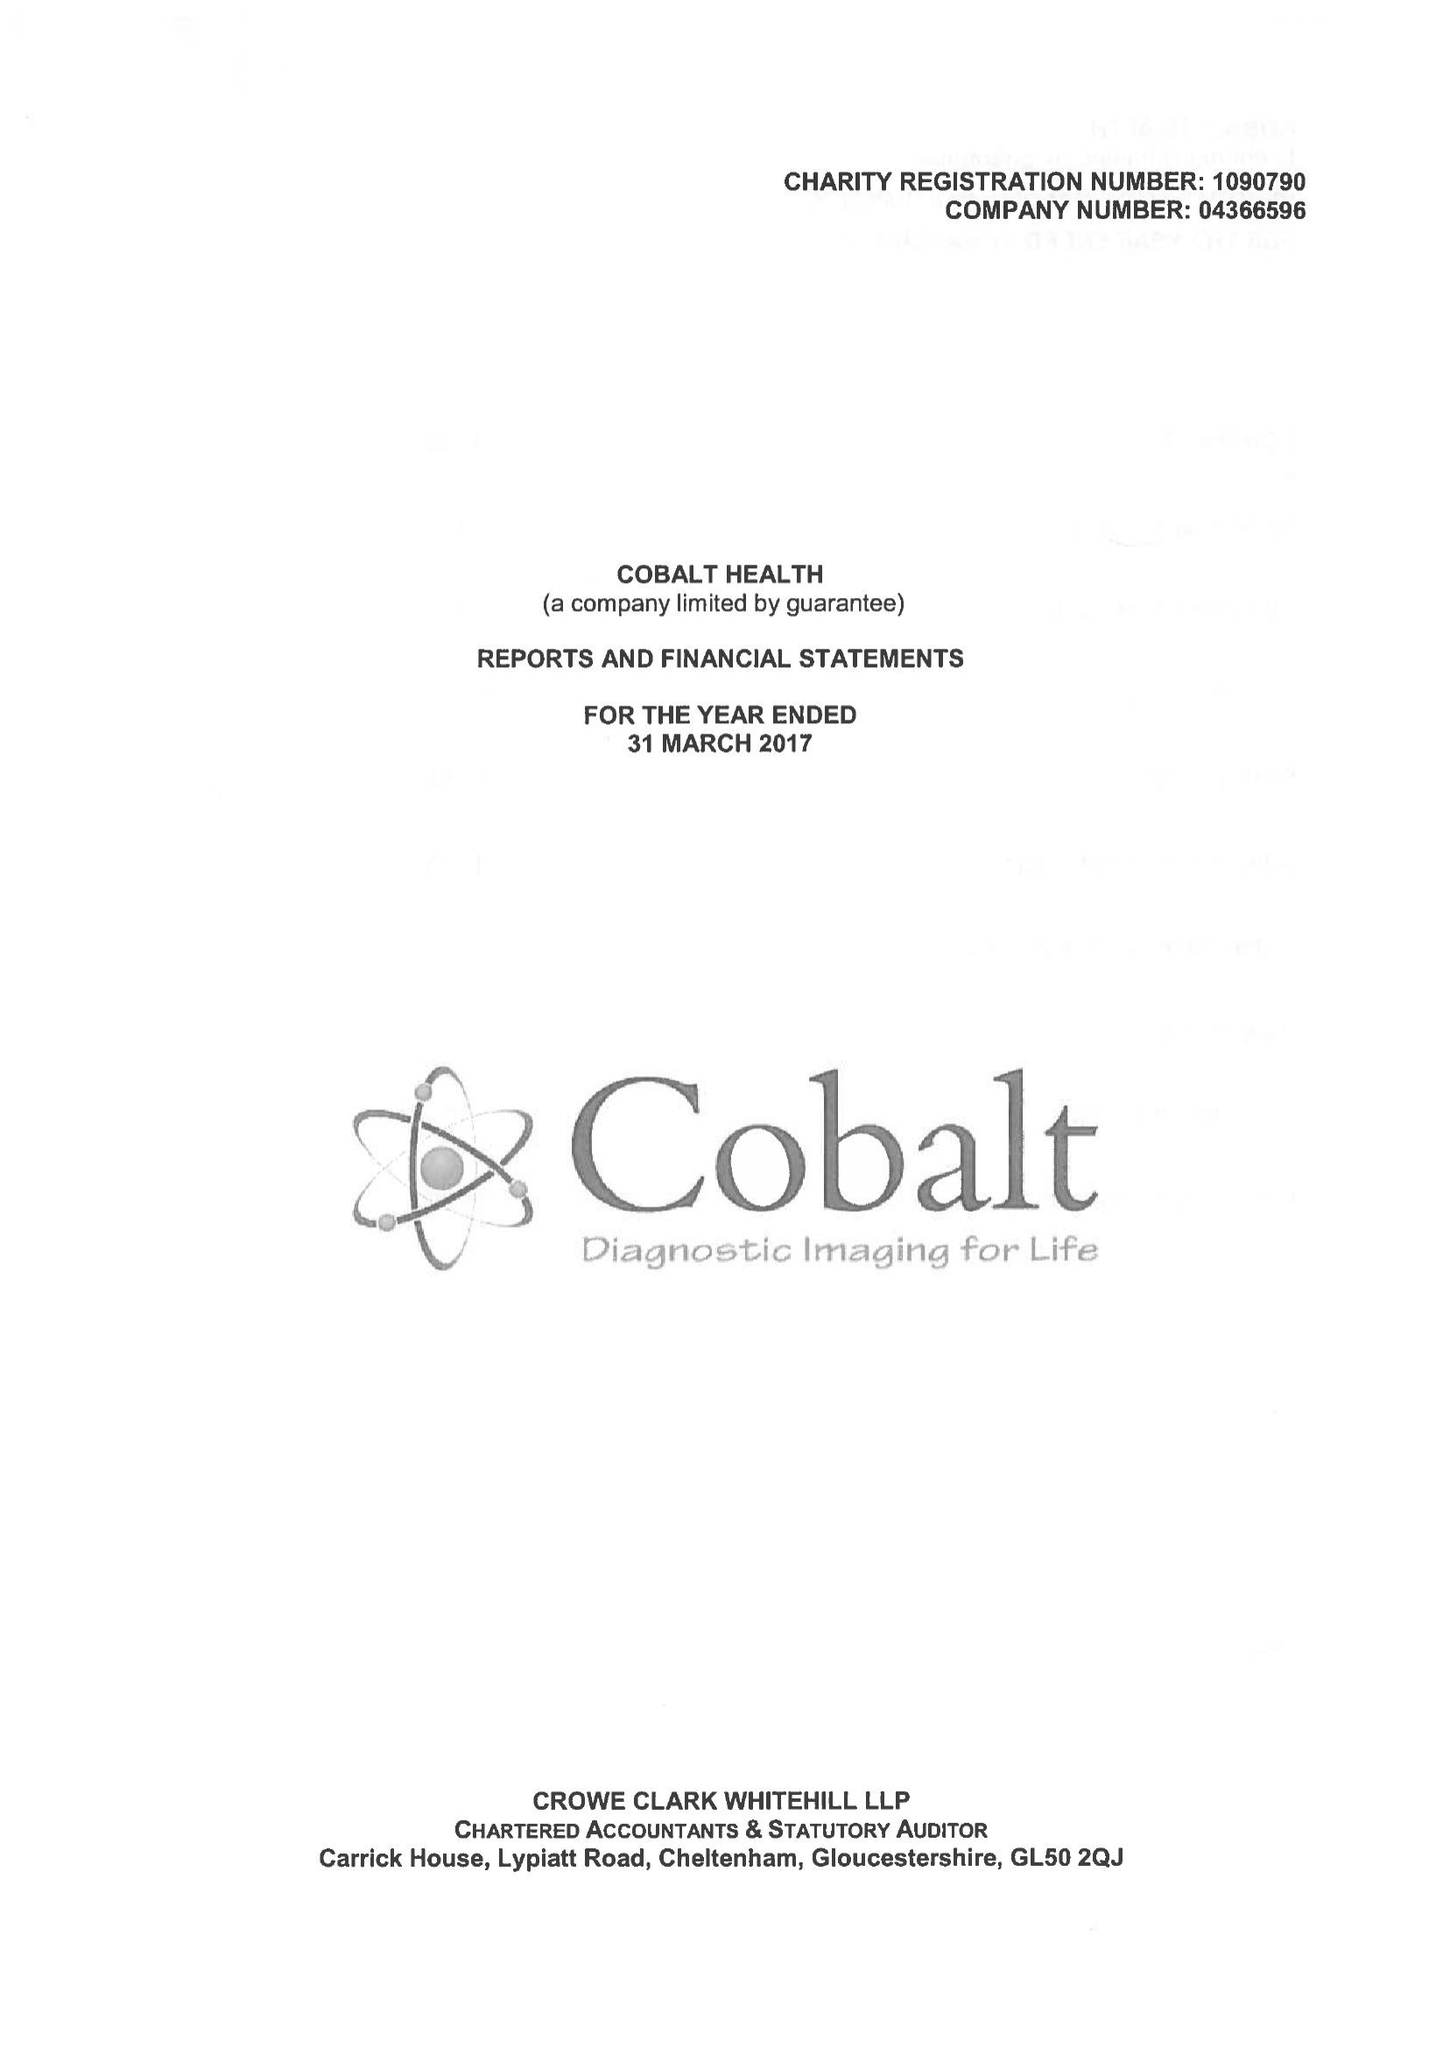What is the value for the spending_annually_in_british_pounds?
Answer the question using a single word or phrase. 8627866.00 